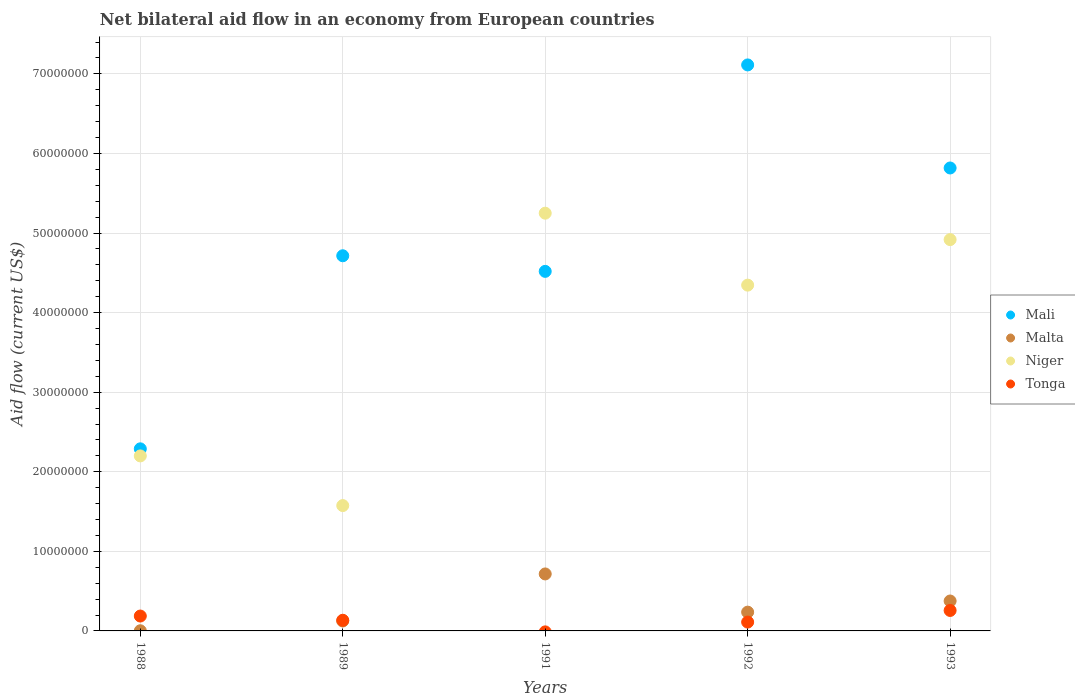How many different coloured dotlines are there?
Provide a succinct answer. 4. What is the net bilateral aid flow in Malta in 1989?
Provide a succinct answer. 1.25e+06. Across all years, what is the maximum net bilateral aid flow in Niger?
Your answer should be compact. 5.25e+07. Across all years, what is the minimum net bilateral aid flow in Mali?
Keep it short and to the point. 2.29e+07. What is the total net bilateral aid flow in Malta in the graph?
Keep it short and to the point. 1.46e+07. What is the difference between the net bilateral aid flow in Niger in 1988 and that in 1993?
Provide a short and direct response. -2.72e+07. What is the difference between the net bilateral aid flow in Mali in 1993 and the net bilateral aid flow in Malta in 1989?
Your answer should be compact. 5.69e+07. What is the average net bilateral aid flow in Mali per year?
Offer a very short reply. 4.89e+07. In the year 1993, what is the difference between the net bilateral aid flow in Niger and net bilateral aid flow in Mali?
Keep it short and to the point. -9.00e+06. What is the ratio of the net bilateral aid flow in Niger in 1989 to that in 1991?
Provide a short and direct response. 0.3. Is the net bilateral aid flow in Mali in 1988 less than that in 1991?
Your response must be concise. Yes. What is the difference between the highest and the second highest net bilateral aid flow in Mali?
Give a very brief answer. 1.30e+07. What is the difference between the highest and the lowest net bilateral aid flow in Malta?
Keep it short and to the point. 7.14e+06. In how many years, is the net bilateral aid flow in Malta greater than the average net bilateral aid flow in Malta taken over all years?
Keep it short and to the point. 2. Is the sum of the net bilateral aid flow in Mali in 1991 and 1992 greater than the maximum net bilateral aid flow in Malta across all years?
Your response must be concise. Yes. Is it the case that in every year, the sum of the net bilateral aid flow in Mali and net bilateral aid flow in Niger  is greater than the sum of net bilateral aid flow in Malta and net bilateral aid flow in Tonga?
Make the answer very short. No. Is it the case that in every year, the sum of the net bilateral aid flow in Malta and net bilateral aid flow in Mali  is greater than the net bilateral aid flow in Tonga?
Offer a very short reply. Yes. Is the net bilateral aid flow in Tonga strictly greater than the net bilateral aid flow in Malta over the years?
Ensure brevity in your answer.  No. How many dotlines are there?
Offer a terse response. 4. Does the graph contain grids?
Your response must be concise. Yes. Where does the legend appear in the graph?
Give a very brief answer. Center right. How many legend labels are there?
Offer a terse response. 4. What is the title of the graph?
Your answer should be very brief. Net bilateral aid flow in an economy from European countries. Does "Palau" appear as one of the legend labels in the graph?
Your answer should be compact. No. What is the label or title of the X-axis?
Keep it short and to the point. Years. What is the label or title of the Y-axis?
Your answer should be compact. Aid flow (current US$). What is the Aid flow (current US$) of Mali in 1988?
Provide a succinct answer. 2.29e+07. What is the Aid flow (current US$) of Malta in 1988?
Your response must be concise. 2.00e+04. What is the Aid flow (current US$) of Niger in 1988?
Give a very brief answer. 2.20e+07. What is the Aid flow (current US$) in Tonga in 1988?
Your answer should be compact. 1.87e+06. What is the Aid flow (current US$) of Mali in 1989?
Provide a succinct answer. 4.71e+07. What is the Aid flow (current US$) of Malta in 1989?
Provide a short and direct response. 1.25e+06. What is the Aid flow (current US$) in Niger in 1989?
Your answer should be very brief. 1.58e+07. What is the Aid flow (current US$) of Tonga in 1989?
Provide a short and direct response. 1.34e+06. What is the Aid flow (current US$) in Mali in 1991?
Your answer should be very brief. 4.52e+07. What is the Aid flow (current US$) of Malta in 1991?
Provide a succinct answer. 7.16e+06. What is the Aid flow (current US$) of Niger in 1991?
Ensure brevity in your answer.  5.25e+07. What is the Aid flow (current US$) in Tonga in 1991?
Keep it short and to the point. 0. What is the Aid flow (current US$) in Mali in 1992?
Offer a very short reply. 7.11e+07. What is the Aid flow (current US$) of Malta in 1992?
Your answer should be compact. 2.36e+06. What is the Aid flow (current US$) in Niger in 1992?
Give a very brief answer. 4.34e+07. What is the Aid flow (current US$) of Tonga in 1992?
Give a very brief answer. 1.11e+06. What is the Aid flow (current US$) in Mali in 1993?
Your answer should be very brief. 5.82e+07. What is the Aid flow (current US$) of Malta in 1993?
Provide a succinct answer. 3.76e+06. What is the Aid flow (current US$) of Niger in 1993?
Offer a very short reply. 4.92e+07. What is the Aid flow (current US$) of Tonga in 1993?
Keep it short and to the point. 2.57e+06. Across all years, what is the maximum Aid flow (current US$) of Mali?
Your response must be concise. 7.11e+07. Across all years, what is the maximum Aid flow (current US$) of Malta?
Ensure brevity in your answer.  7.16e+06. Across all years, what is the maximum Aid flow (current US$) of Niger?
Provide a short and direct response. 5.25e+07. Across all years, what is the maximum Aid flow (current US$) in Tonga?
Offer a very short reply. 2.57e+06. Across all years, what is the minimum Aid flow (current US$) of Mali?
Provide a succinct answer. 2.29e+07. Across all years, what is the minimum Aid flow (current US$) in Malta?
Make the answer very short. 2.00e+04. Across all years, what is the minimum Aid flow (current US$) of Niger?
Offer a terse response. 1.58e+07. What is the total Aid flow (current US$) of Mali in the graph?
Give a very brief answer. 2.44e+08. What is the total Aid flow (current US$) of Malta in the graph?
Offer a very short reply. 1.46e+07. What is the total Aid flow (current US$) in Niger in the graph?
Your answer should be very brief. 1.83e+08. What is the total Aid flow (current US$) in Tonga in the graph?
Provide a short and direct response. 6.89e+06. What is the difference between the Aid flow (current US$) in Mali in 1988 and that in 1989?
Provide a short and direct response. -2.43e+07. What is the difference between the Aid flow (current US$) in Malta in 1988 and that in 1989?
Offer a terse response. -1.23e+06. What is the difference between the Aid flow (current US$) in Niger in 1988 and that in 1989?
Your answer should be very brief. 6.24e+06. What is the difference between the Aid flow (current US$) of Tonga in 1988 and that in 1989?
Offer a very short reply. 5.30e+05. What is the difference between the Aid flow (current US$) of Mali in 1988 and that in 1991?
Your response must be concise. -2.23e+07. What is the difference between the Aid flow (current US$) in Malta in 1988 and that in 1991?
Your response must be concise. -7.14e+06. What is the difference between the Aid flow (current US$) in Niger in 1988 and that in 1991?
Your answer should be compact. -3.05e+07. What is the difference between the Aid flow (current US$) in Mali in 1988 and that in 1992?
Ensure brevity in your answer.  -4.82e+07. What is the difference between the Aid flow (current US$) in Malta in 1988 and that in 1992?
Give a very brief answer. -2.34e+06. What is the difference between the Aid flow (current US$) of Niger in 1988 and that in 1992?
Your answer should be very brief. -2.15e+07. What is the difference between the Aid flow (current US$) in Tonga in 1988 and that in 1992?
Offer a very short reply. 7.60e+05. What is the difference between the Aid flow (current US$) in Mali in 1988 and that in 1993?
Make the answer very short. -3.53e+07. What is the difference between the Aid flow (current US$) in Malta in 1988 and that in 1993?
Offer a very short reply. -3.74e+06. What is the difference between the Aid flow (current US$) in Niger in 1988 and that in 1993?
Provide a succinct answer. -2.72e+07. What is the difference between the Aid flow (current US$) in Tonga in 1988 and that in 1993?
Your response must be concise. -7.00e+05. What is the difference between the Aid flow (current US$) of Mali in 1989 and that in 1991?
Offer a terse response. 1.96e+06. What is the difference between the Aid flow (current US$) in Malta in 1989 and that in 1991?
Ensure brevity in your answer.  -5.91e+06. What is the difference between the Aid flow (current US$) of Niger in 1989 and that in 1991?
Offer a terse response. -3.67e+07. What is the difference between the Aid flow (current US$) in Mali in 1989 and that in 1992?
Provide a short and direct response. -2.40e+07. What is the difference between the Aid flow (current US$) in Malta in 1989 and that in 1992?
Ensure brevity in your answer.  -1.11e+06. What is the difference between the Aid flow (current US$) of Niger in 1989 and that in 1992?
Make the answer very short. -2.77e+07. What is the difference between the Aid flow (current US$) of Mali in 1989 and that in 1993?
Offer a terse response. -1.10e+07. What is the difference between the Aid flow (current US$) of Malta in 1989 and that in 1993?
Give a very brief answer. -2.51e+06. What is the difference between the Aid flow (current US$) in Niger in 1989 and that in 1993?
Provide a short and direct response. -3.34e+07. What is the difference between the Aid flow (current US$) of Tonga in 1989 and that in 1993?
Provide a succinct answer. -1.23e+06. What is the difference between the Aid flow (current US$) of Mali in 1991 and that in 1992?
Your response must be concise. -2.59e+07. What is the difference between the Aid flow (current US$) in Malta in 1991 and that in 1992?
Offer a very short reply. 4.80e+06. What is the difference between the Aid flow (current US$) of Niger in 1991 and that in 1992?
Make the answer very short. 9.04e+06. What is the difference between the Aid flow (current US$) of Mali in 1991 and that in 1993?
Your answer should be very brief. -1.30e+07. What is the difference between the Aid flow (current US$) of Malta in 1991 and that in 1993?
Your response must be concise. 3.40e+06. What is the difference between the Aid flow (current US$) of Niger in 1991 and that in 1993?
Provide a succinct answer. 3.32e+06. What is the difference between the Aid flow (current US$) of Mali in 1992 and that in 1993?
Give a very brief answer. 1.30e+07. What is the difference between the Aid flow (current US$) of Malta in 1992 and that in 1993?
Your answer should be very brief. -1.40e+06. What is the difference between the Aid flow (current US$) in Niger in 1992 and that in 1993?
Your answer should be compact. -5.72e+06. What is the difference between the Aid flow (current US$) of Tonga in 1992 and that in 1993?
Give a very brief answer. -1.46e+06. What is the difference between the Aid flow (current US$) in Mali in 1988 and the Aid flow (current US$) in Malta in 1989?
Make the answer very short. 2.16e+07. What is the difference between the Aid flow (current US$) in Mali in 1988 and the Aid flow (current US$) in Niger in 1989?
Keep it short and to the point. 7.13e+06. What is the difference between the Aid flow (current US$) of Mali in 1988 and the Aid flow (current US$) of Tonga in 1989?
Your answer should be compact. 2.15e+07. What is the difference between the Aid flow (current US$) in Malta in 1988 and the Aid flow (current US$) in Niger in 1989?
Make the answer very short. -1.57e+07. What is the difference between the Aid flow (current US$) in Malta in 1988 and the Aid flow (current US$) in Tonga in 1989?
Make the answer very short. -1.32e+06. What is the difference between the Aid flow (current US$) of Niger in 1988 and the Aid flow (current US$) of Tonga in 1989?
Ensure brevity in your answer.  2.06e+07. What is the difference between the Aid flow (current US$) in Mali in 1988 and the Aid flow (current US$) in Malta in 1991?
Make the answer very short. 1.57e+07. What is the difference between the Aid flow (current US$) in Mali in 1988 and the Aid flow (current US$) in Niger in 1991?
Offer a terse response. -2.96e+07. What is the difference between the Aid flow (current US$) of Malta in 1988 and the Aid flow (current US$) of Niger in 1991?
Make the answer very short. -5.25e+07. What is the difference between the Aid flow (current US$) in Mali in 1988 and the Aid flow (current US$) in Malta in 1992?
Keep it short and to the point. 2.05e+07. What is the difference between the Aid flow (current US$) of Mali in 1988 and the Aid flow (current US$) of Niger in 1992?
Your answer should be very brief. -2.06e+07. What is the difference between the Aid flow (current US$) in Mali in 1988 and the Aid flow (current US$) in Tonga in 1992?
Make the answer very short. 2.18e+07. What is the difference between the Aid flow (current US$) in Malta in 1988 and the Aid flow (current US$) in Niger in 1992?
Provide a succinct answer. -4.34e+07. What is the difference between the Aid flow (current US$) of Malta in 1988 and the Aid flow (current US$) of Tonga in 1992?
Provide a short and direct response. -1.09e+06. What is the difference between the Aid flow (current US$) of Niger in 1988 and the Aid flow (current US$) of Tonga in 1992?
Offer a terse response. 2.09e+07. What is the difference between the Aid flow (current US$) of Mali in 1988 and the Aid flow (current US$) of Malta in 1993?
Your response must be concise. 1.91e+07. What is the difference between the Aid flow (current US$) of Mali in 1988 and the Aid flow (current US$) of Niger in 1993?
Keep it short and to the point. -2.63e+07. What is the difference between the Aid flow (current US$) in Mali in 1988 and the Aid flow (current US$) in Tonga in 1993?
Your answer should be very brief. 2.03e+07. What is the difference between the Aid flow (current US$) of Malta in 1988 and the Aid flow (current US$) of Niger in 1993?
Your answer should be compact. -4.92e+07. What is the difference between the Aid flow (current US$) of Malta in 1988 and the Aid flow (current US$) of Tonga in 1993?
Your answer should be compact. -2.55e+06. What is the difference between the Aid flow (current US$) in Niger in 1988 and the Aid flow (current US$) in Tonga in 1993?
Offer a very short reply. 1.94e+07. What is the difference between the Aid flow (current US$) in Mali in 1989 and the Aid flow (current US$) in Malta in 1991?
Give a very brief answer. 4.00e+07. What is the difference between the Aid flow (current US$) in Mali in 1989 and the Aid flow (current US$) in Niger in 1991?
Keep it short and to the point. -5.35e+06. What is the difference between the Aid flow (current US$) of Malta in 1989 and the Aid flow (current US$) of Niger in 1991?
Keep it short and to the point. -5.12e+07. What is the difference between the Aid flow (current US$) of Mali in 1989 and the Aid flow (current US$) of Malta in 1992?
Provide a succinct answer. 4.48e+07. What is the difference between the Aid flow (current US$) in Mali in 1989 and the Aid flow (current US$) in Niger in 1992?
Offer a very short reply. 3.69e+06. What is the difference between the Aid flow (current US$) of Mali in 1989 and the Aid flow (current US$) of Tonga in 1992?
Offer a very short reply. 4.60e+07. What is the difference between the Aid flow (current US$) of Malta in 1989 and the Aid flow (current US$) of Niger in 1992?
Offer a terse response. -4.22e+07. What is the difference between the Aid flow (current US$) of Niger in 1989 and the Aid flow (current US$) of Tonga in 1992?
Your answer should be compact. 1.46e+07. What is the difference between the Aid flow (current US$) in Mali in 1989 and the Aid flow (current US$) in Malta in 1993?
Make the answer very short. 4.34e+07. What is the difference between the Aid flow (current US$) in Mali in 1989 and the Aid flow (current US$) in Niger in 1993?
Your response must be concise. -2.03e+06. What is the difference between the Aid flow (current US$) in Mali in 1989 and the Aid flow (current US$) in Tonga in 1993?
Offer a very short reply. 4.46e+07. What is the difference between the Aid flow (current US$) in Malta in 1989 and the Aid flow (current US$) in Niger in 1993?
Your answer should be compact. -4.79e+07. What is the difference between the Aid flow (current US$) in Malta in 1989 and the Aid flow (current US$) in Tonga in 1993?
Your answer should be very brief. -1.32e+06. What is the difference between the Aid flow (current US$) in Niger in 1989 and the Aid flow (current US$) in Tonga in 1993?
Make the answer very short. 1.32e+07. What is the difference between the Aid flow (current US$) in Mali in 1991 and the Aid flow (current US$) in Malta in 1992?
Your answer should be compact. 4.28e+07. What is the difference between the Aid flow (current US$) of Mali in 1991 and the Aid flow (current US$) of Niger in 1992?
Your answer should be very brief. 1.73e+06. What is the difference between the Aid flow (current US$) in Mali in 1991 and the Aid flow (current US$) in Tonga in 1992?
Make the answer very short. 4.41e+07. What is the difference between the Aid flow (current US$) in Malta in 1991 and the Aid flow (current US$) in Niger in 1992?
Your answer should be compact. -3.63e+07. What is the difference between the Aid flow (current US$) of Malta in 1991 and the Aid flow (current US$) of Tonga in 1992?
Provide a short and direct response. 6.05e+06. What is the difference between the Aid flow (current US$) in Niger in 1991 and the Aid flow (current US$) in Tonga in 1992?
Provide a short and direct response. 5.14e+07. What is the difference between the Aid flow (current US$) of Mali in 1991 and the Aid flow (current US$) of Malta in 1993?
Offer a terse response. 4.14e+07. What is the difference between the Aid flow (current US$) in Mali in 1991 and the Aid flow (current US$) in Niger in 1993?
Give a very brief answer. -3.99e+06. What is the difference between the Aid flow (current US$) in Mali in 1991 and the Aid flow (current US$) in Tonga in 1993?
Your response must be concise. 4.26e+07. What is the difference between the Aid flow (current US$) in Malta in 1991 and the Aid flow (current US$) in Niger in 1993?
Make the answer very short. -4.20e+07. What is the difference between the Aid flow (current US$) of Malta in 1991 and the Aid flow (current US$) of Tonga in 1993?
Provide a short and direct response. 4.59e+06. What is the difference between the Aid flow (current US$) of Niger in 1991 and the Aid flow (current US$) of Tonga in 1993?
Give a very brief answer. 4.99e+07. What is the difference between the Aid flow (current US$) of Mali in 1992 and the Aid flow (current US$) of Malta in 1993?
Ensure brevity in your answer.  6.74e+07. What is the difference between the Aid flow (current US$) in Mali in 1992 and the Aid flow (current US$) in Niger in 1993?
Provide a succinct answer. 2.20e+07. What is the difference between the Aid flow (current US$) of Mali in 1992 and the Aid flow (current US$) of Tonga in 1993?
Offer a very short reply. 6.86e+07. What is the difference between the Aid flow (current US$) in Malta in 1992 and the Aid flow (current US$) in Niger in 1993?
Offer a very short reply. -4.68e+07. What is the difference between the Aid flow (current US$) in Niger in 1992 and the Aid flow (current US$) in Tonga in 1993?
Your response must be concise. 4.09e+07. What is the average Aid flow (current US$) of Mali per year?
Offer a terse response. 4.89e+07. What is the average Aid flow (current US$) of Malta per year?
Provide a succinct answer. 2.91e+06. What is the average Aid flow (current US$) of Niger per year?
Provide a short and direct response. 3.66e+07. What is the average Aid flow (current US$) of Tonga per year?
Ensure brevity in your answer.  1.38e+06. In the year 1988, what is the difference between the Aid flow (current US$) in Mali and Aid flow (current US$) in Malta?
Your answer should be compact. 2.29e+07. In the year 1988, what is the difference between the Aid flow (current US$) of Mali and Aid flow (current US$) of Niger?
Your answer should be compact. 8.90e+05. In the year 1988, what is the difference between the Aid flow (current US$) in Mali and Aid flow (current US$) in Tonga?
Make the answer very short. 2.10e+07. In the year 1988, what is the difference between the Aid flow (current US$) in Malta and Aid flow (current US$) in Niger?
Keep it short and to the point. -2.20e+07. In the year 1988, what is the difference between the Aid flow (current US$) in Malta and Aid flow (current US$) in Tonga?
Make the answer very short. -1.85e+06. In the year 1988, what is the difference between the Aid flow (current US$) of Niger and Aid flow (current US$) of Tonga?
Offer a very short reply. 2.01e+07. In the year 1989, what is the difference between the Aid flow (current US$) in Mali and Aid flow (current US$) in Malta?
Offer a terse response. 4.59e+07. In the year 1989, what is the difference between the Aid flow (current US$) in Mali and Aid flow (current US$) in Niger?
Keep it short and to the point. 3.14e+07. In the year 1989, what is the difference between the Aid flow (current US$) in Mali and Aid flow (current US$) in Tonga?
Your response must be concise. 4.58e+07. In the year 1989, what is the difference between the Aid flow (current US$) of Malta and Aid flow (current US$) of Niger?
Ensure brevity in your answer.  -1.45e+07. In the year 1989, what is the difference between the Aid flow (current US$) of Niger and Aid flow (current US$) of Tonga?
Make the answer very short. 1.44e+07. In the year 1991, what is the difference between the Aid flow (current US$) in Mali and Aid flow (current US$) in Malta?
Your answer should be compact. 3.80e+07. In the year 1991, what is the difference between the Aid flow (current US$) in Mali and Aid flow (current US$) in Niger?
Provide a short and direct response. -7.31e+06. In the year 1991, what is the difference between the Aid flow (current US$) in Malta and Aid flow (current US$) in Niger?
Keep it short and to the point. -4.53e+07. In the year 1992, what is the difference between the Aid flow (current US$) of Mali and Aid flow (current US$) of Malta?
Keep it short and to the point. 6.88e+07. In the year 1992, what is the difference between the Aid flow (current US$) in Mali and Aid flow (current US$) in Niger?
Your response must be concise. 2.77e+07. In the year 1992, what is the difference between the Aid flow (current US$) of Mali and Aid flow (current US$) of Tonga?
Offer a very short reply. 7.00e+07. In the year 1992, what is the difference between the Aid flow (current US$) in Malta and Aid flow (current US$) in Niger?
Your response must be concise. -4.11e+07. In the year 1992, what is the difference between the Aid flow (current US$) of Malta and Aid flow (current US$) of Tonga?
Offer a very short reply. 1.25e+06. In the year 1992, what is the difference between the Aid flow (current US$) in Niger and Aid flow (current US$) in Tonga?
Your response must be concise. 4.23e+07. In the year 1993, what is the difference between the Aid flow (current US$) in Mali and Aid flow (current US$) in Malta?
Give a very brief answer. 5.44e+07. In the year 1993, what is the difference between the Aid flow (current US$) of Mali and Aid flow (current US$) of Niger?
Your answer should be very brief. 9.00e+06. In the year 1993, what is the difference between the Aid flow (current US$) in Mali and Aid flow (current US$) in Tonga?
Your response must be concise. 5.56e+07. In the year 1993, what is the difference between the Aid flow (current US$) of Malta and Aid flow (current US$) of Niger?
Your response must be concise. -4.54e+07. In the year 1993, what is the difference between the Aid flow (current US$) in Malta and Aid flow (current US$) in Tonga?
Keep it short and to the point. 1.19e+06. In the year 1993, what is the difference between the Aid flow (current US$) of Niger and Aid flow (current US$) of Tonga?
Keep it short and to the point. 4.66e+07. What is the ratio of the Aid flow (current US$) of Mali in 1988 to that in 1989?
Ensure brevity in your answer.  0.49. What is the ratio of the Aid flow (current US$) in Malta in 1988 to that in 1989?
Offer a terse response. 0.02. What is the ratio of the Aid flow (current US$) in Niger in 1988 to that in 1989?
Provide a short and direct response. 1.4. What is the ratio of the Aid flow (current US$) in Tonga in 1988 to that in 1989?
Provide a short and direct response. 1.4. What is the ratio of the Aid flow (current US$) in Mali in 1988 to that in 1991?
Give a very brief answer. 0.51. What is the ratio of the Aid flow (current US$) of Malta in 1988 to that in 1991?
Your answer should be compact. 0. What is the ratio of the Aid flow (current US$) in Niger in 1988 to that in 1991?
Ensure brevity in your answer.  0.42. What is the ratio of the Aid flow (current US$) of Mali in 1988 to that in 1992?
Offer a terse response. 0.32. What is the ratio of the Aid flow (current US$) of Malta in 1988 to that in 1992?
Your answer should be compact. 0.01. What is the ratio of the Aid flow (current US$) of Niger in 1988 to that in 1992?
Your answer should be compact. 0.51. What is the ratio of the Aid flow (current US$) of Tonga in 1988 to that in 1992?
Your answer should be compact. 1.68. What is the ratio of the Aid flow (current US$) of Mali in 1988 to that in 1993?
Give a very brief answer. 0.39. What is the ratio of the Aid flow (current US$) of Malta in 1988 to that in 1993?
Provide a short and direct response. 0.01. What is the ratio of the Aid flow (current US$) in Niger in 1988 to that in 1993?
Make the answer very short. 0.45. What is the ratio of the Aid flow (current US$) of Tonga in 1988 to that in 1993?
Your answer should be very brief. 0.73. What is the ratio of the Aid flow (current US$) of Mali in 1989 to that in 1991?
Provide a short and direct response. 1.04. What is the ratio of the Aid flow (current US$) in Malta in 1989 to that in 1991?
Make the answer very short. 0.17. What is the ratio of the Aid flow (current US$) in Niger in 1989 to that in 1991?
Provide a short and direct response. 0.3. What is the ratio of the Aid flow (current US$) of Mali in 1989 to that in 1992?
Your answer should be compact. 0.66. What is the ratio of the Aid flow (current US$) of Malta in 1989 to that in 1992?
Offer a very short reply. 0.53. What is the ratio of the Aid flow (current US$) of Niger in 1989 to that in 1992?
Your answer should be compact. 0.36. What is the ratio of the Aid flow (current US$) in Tonga in 1989 to that in 1992?
Provide a short and direct response. 1.21. What is the ratio of the Aid flow (current US$) of Mali in 1989 to that in 1993?
Make the answer very short. 0.81. What is the ratio of the Aid flow (current US$) in Malta in 1989 to that in 1993?
Provide a short and direct response. 0.33. What is the ratio of the Aid flow (current US$) of Niger in 1989 to that in 1993?
Give a very brief answer. 0.32. What is the ratio of the Aid flow (current US$) of Tonga in 1989 to that in 1993?
Make the answer very short. 0.52. What is the ratio of the Aid flow (current US$) of Mali in 1991 to that in 1992?
Provide a succinct answer. 0.64. What is the ratio of the Aid flow (current US$) of Malta in 1991 to that in 1992?
Offer a terse response. 3.03. What is the ratio of the Aid flow (current US$) in Niger in 1991 to that in 1992?
Offer a very short reply. 1.21. What is the ratio of the Aid flow (current US$) in Mali in 1991 to that in 1993?
Provide a short and direct response. 0.78. What is the ratio of the Aid flow (current US$) in Malta in 1991 to that in 1993?
Your answer should be very brief. 1.9. What is the ratio of the Aid flow (current US$) of Niger in 1991 to that in 1993?
Offer a terse response. 1.07. What is the ratio of the Aid flow (current US$) of Mali in 1992 to that in 1993?
Make the answer very short. 1.22. What is the ratio of the Aid flow (current US$) in Malta in 1992 to that in 1993?
Provide a succinct answer. 0.63. What is the ratio of the Aid flow (current US$) of Niger in 1992 to that in 1993?
Offer a very short reply. 0.88. What is the ratio of the Aid flow (current US$) of Tonga in 1992 to that in 1993?
Provide a short and direct response. 0.43. What is the difference between the highest and the second highest Aid flow (current US$) in Mali?
Give a very brief answer. 1.30e+07. What is the difference between the highest and the second highest Aid flow (current US$) of Malta?
Your response must be concise. 3.40e+06. What is the difference between the highest and the second highest Aid flow (current US$) of Niger?
Your answer should be compact. 3.32e+06. What is the difference between the highest and the second highest Aid flow (current US$) in Tonga?
Give a very brief answer. 7.00e+05. What is the difference between the highest and the lowest Aid flow (current US$) in Mali?
Ensure brevity in your answer.  4.82e+07. What is the difference between the highest and the lowest Aid flow (current US$) in Malta?
Keep it short and to the point. 7.14e+06. What is the difference between the highest and the lowest Aid flow (current US$) in Niger?
Offer a very short reply. 3.67e+07. What is the difference between the highest and the lowest Aid flow (current US$) in Tonga?
Offer a terse response. 2.57e+06. 